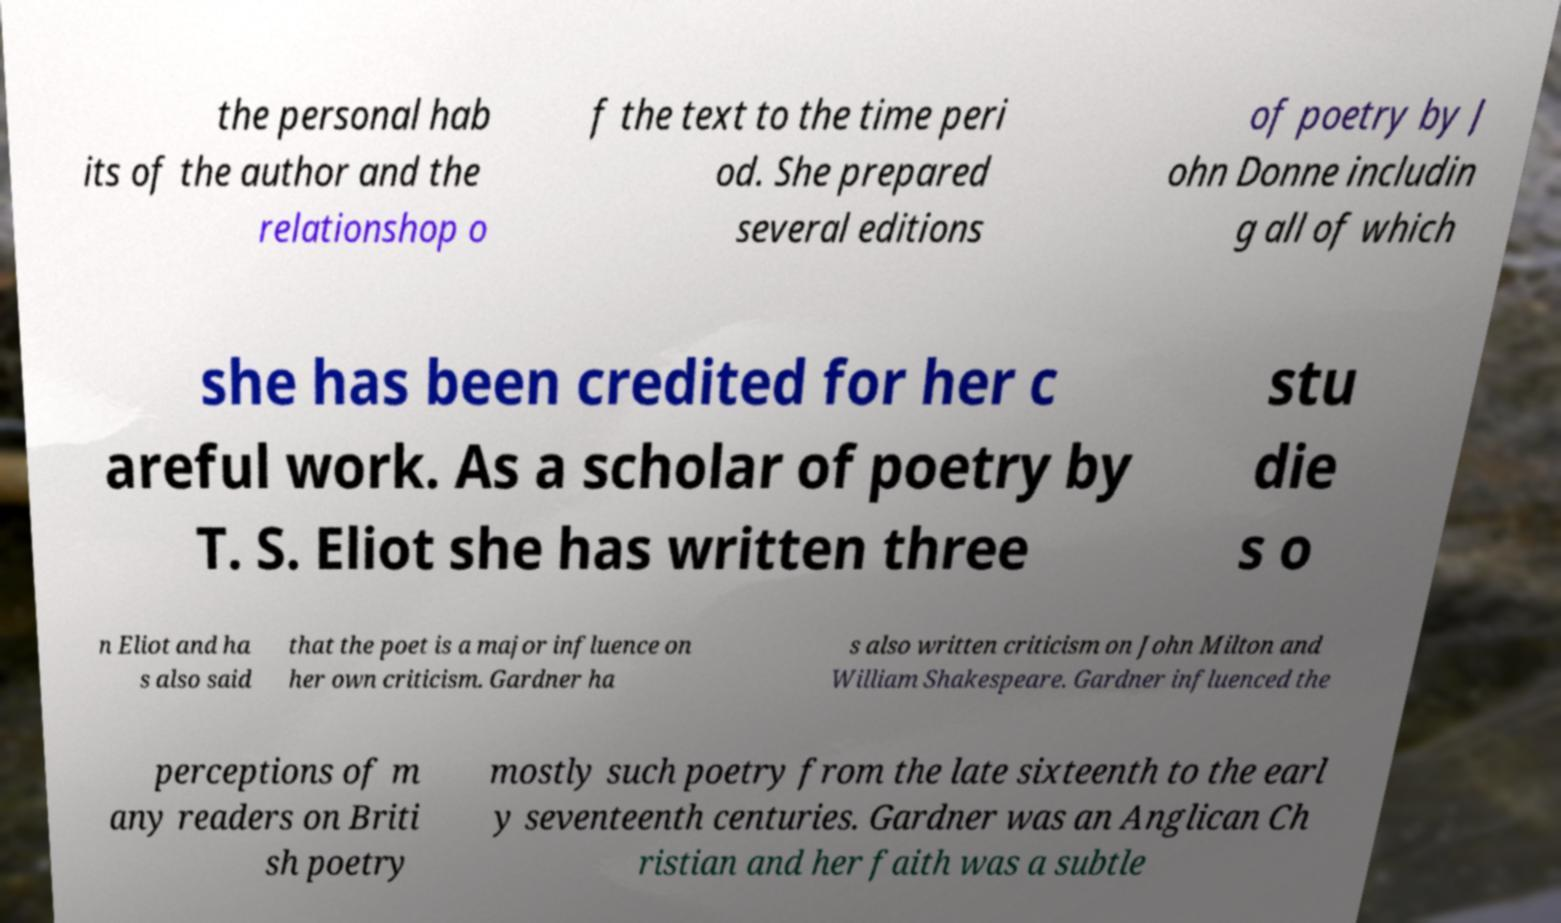Can you accurately transcribe the text from the provided image for me? the personal hab its of the author and the relationshop o f the text to the time peri od. She prepared several editions of poetry by J ohn Donne includin g all of which she has been credited for her c areful work. As a scholar of poetry by T. S. Eliot she has written three stu die s o n Eliot and ha s also said that the poet is a major influence on her own criticism. Gardner ha s also written criticism on John Milton and William Shakespeare. Gardner influenced the perceptions of m any readers on Briti sh poetry mostly such poetry from the late sixteenth to the earl y seventeenth centuries. Gardner was an Anglican Ch ristian and her faith was a subtle 